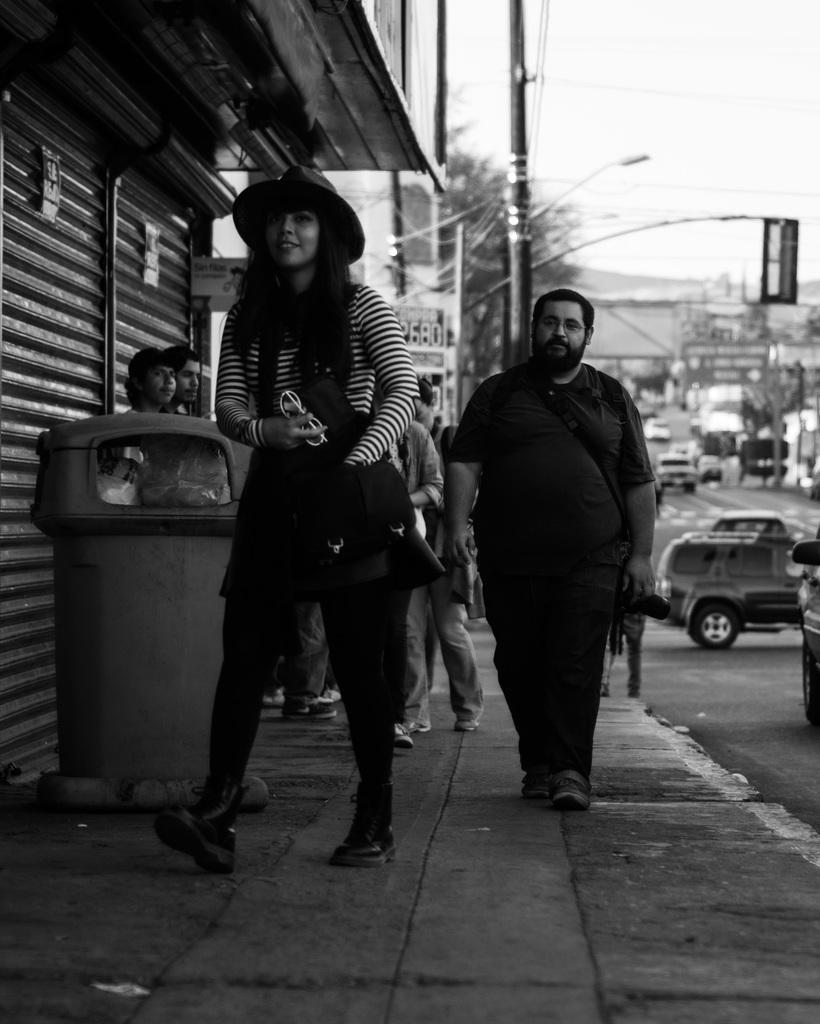What is the girl in the image wearing on her head? The girl in the image is wearing a cap. What are the people in the image doing? The people in the image are sitting. What object can be seen in the image that is used to control light? There is a shutter in the image that is used to control light. What type of vehicles can be seen in the image? Cars are visible in the image. Can you see a stranger driving a tank across the bridge in the image? No, there is no stranger, tank, or bridge present in the image. 